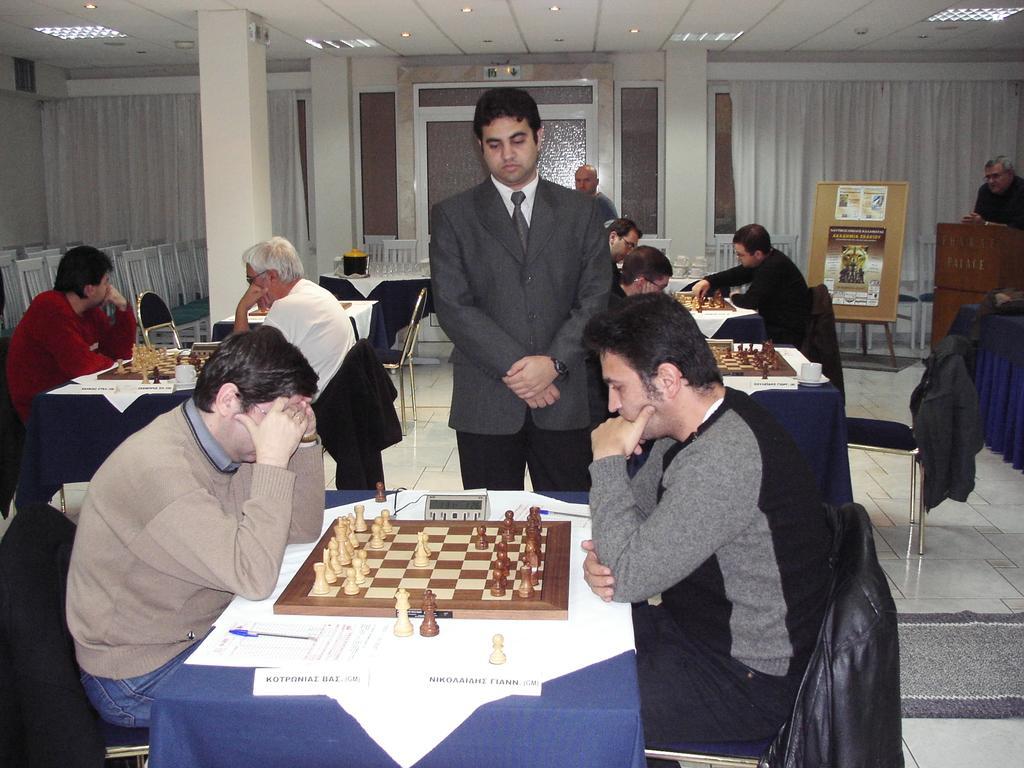Please provide a concise description of this image. In this room a chess competition is being taken place. There are many men playing chess. On the right a man with gray t-shirt and on the left a man in brown sweater are playing chess. And there are white curtains in the background on the left an the right and white ceiling. In the center a man with gray suit is standing and looking at the chess game. On the right corner a man near the podium is standing and looking at everybody playing chess. 